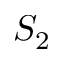Convert formula to latex. <formula><loc_0><loc_0><loc_500><loc_500>S _ { 2 }</formula> 